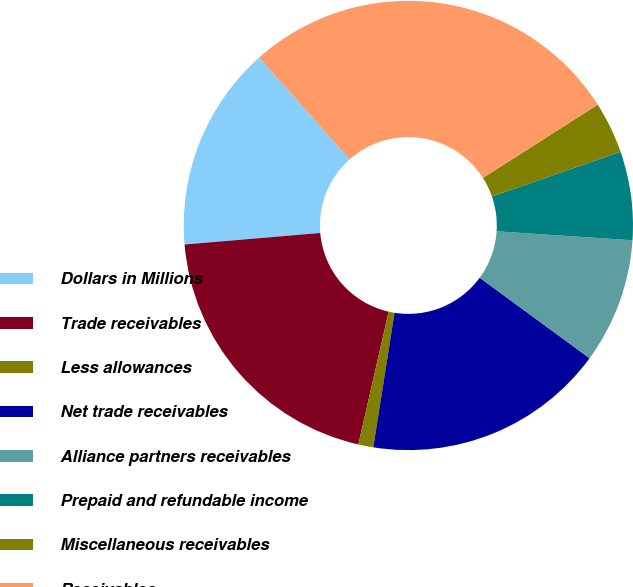<chart> <loc_0><loc_0><loc_500><loc_500><pie_chart><fcel>Dollars in Millions<fcel>Trade receivables<fcel>Less allowances<fcel>Net trade receivables<fcel>Alliance partners receivables<fcel>Prepaid and refundable income<fcel>Miscellaneous receivables<fcel>Receivables<nl><fcel>14.79%<fcel>20.07%<fcel>1.08%<fcel>17.43%<fcel>9.01%<fcel>6.37%<fcel>3.72%<fcel>27.52%<nl></chart> 